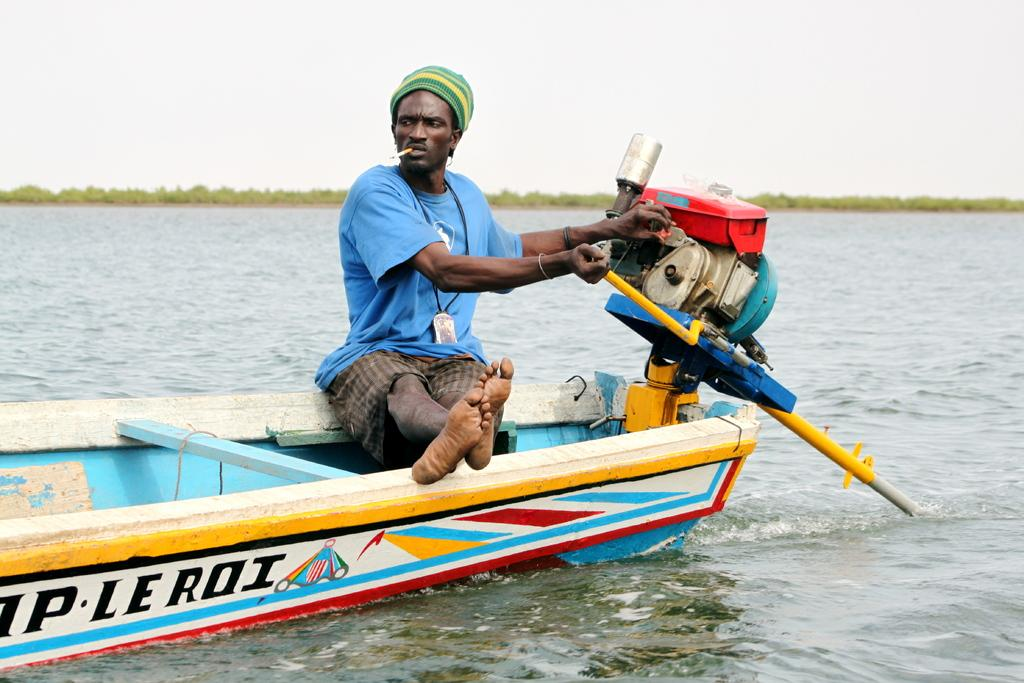Who is present in the image? There is a man in the image. What is the man doing in the image? The man is sitting on a boat and smoking. What is the man holding in the image? The man is holding a machine. What can be seen around the boat in the image? There is water visible in the image. What is visible in the background of the image? There are trees and the sky visible in the background of the image. What is the chance of finding a cave in the image? There is no mention of a cave in the image, so it cannot be determined if there is a chance of finding one. 